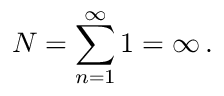<formula> <loc_0><loc_0><loc_500><loc_500>N = \sum _ { n = 1 } ^ { \infty } 1 = \infty \, { . }</formula> 